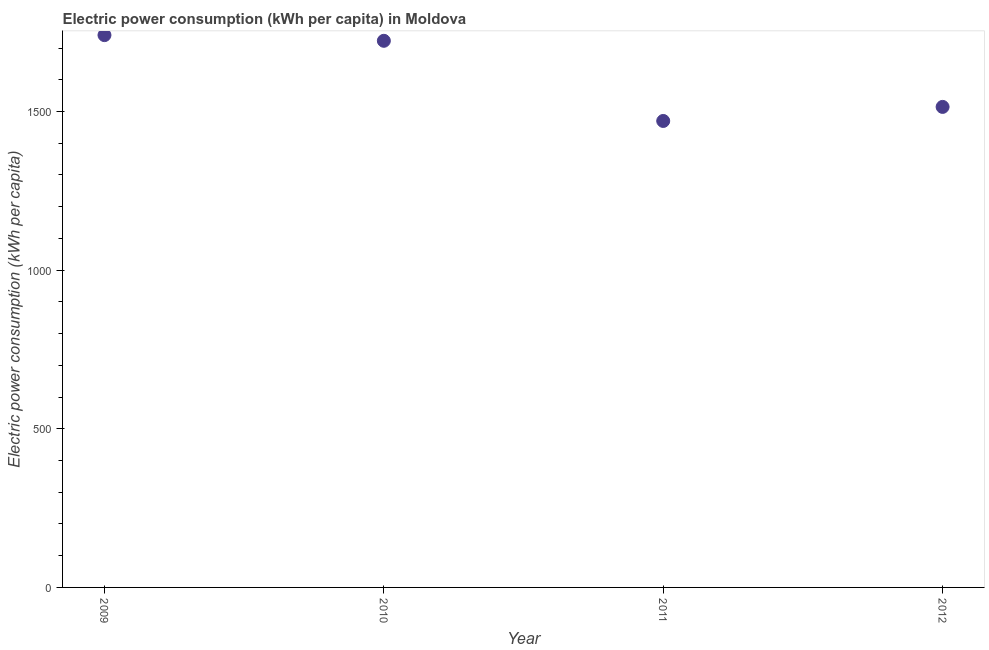What is the electric power consumption in 2009?
Your answer should be compact. 1740.8. Across all years, what is the maximum electric power consumption?
Your response must be concise. 1740.8. Across all years, what is the minimum electric power consumption?
Your answer should be compact. 1470.23. In which year was the electric power consumption minimum?
Provide a short and direct response. 2011. What is the sum of the electric power consumption?
Provide a succinct answer. 6448.45. What is the difference between the electric power consumption in 2009 and 2011?
Give a very brief answer. 270.57. What is the average electric power consumption per year?
Provide a short and direct response. 1612.11. What is the median electric power consumption?
Provide a short and direct response. 1618.71. In how many years, is the electric power consumption greater than 200 kWh per capita?
Offer a very short reply. 4. Do a majority of the years between 2012 and 2011 (inclusive) have electric power consumption greater than 300 kWh per capita?
Provide a succinct answer. No. What is the ratio of the electric power consumption in 2010 to that in 2012?
Offer a very short reply. 1.14. What is the difference between the highest and the second highest electric power consumption?
Your answer should be very brief. 17.91. Is the sum of the electric power consumption in 2009 and 2011 greater than the maximum electric power consumption across all years?
Give a very brief answer. Yes. What is the difference between the highest and the lowest electric power consumption?
Offer a very short reply. 270.57. In how many years, is the electric power consumption greater than the average electric power consumption taken over all years?
Give a very brief answer. 2. Does the electric power consumption monotonically increase over the years?
Offer a terse response. No. How many years are there in the graph?
Provide a short and direct response. 4. Are the values on the major ticks of Y-axis written in scientific E-notation?
Your response must be concise. No. Does the graph contain any zero values?
Provide a succinct answer. No. Does the graph contain grids?
Give a very brief answer. No. What is the title of the graph?
Ensure brevity in your answer.  Electric power consumption (kWh per capita) in Moldova. What is the label or title of the X-axis?
Ensure brevity in your answer.  Year. What is the label or title of the Y-axis?
Your answer should be compact. Electric power consumption (kWh per capita). What is the Electric power consumption (kWh per capita) in 2009?
Your answer should be very brief. 1740.8. What is the Electric power consumption (kWh per capita) in 2010?
Ensure brevity in your answer.  1722.89. What is the Electric power consumption (kWh per capita) in 2011?
Make the answer very short. 1470.23. What is the Electric power consumption (kWh per capita) in 2012?
Offer a very short reply. 1514.53. What is the difference between the Electric power consumption (kWh per capita) in 2009 and 2010?
Provide a short and direct response. 17.91. What is the difference between the Electric power consumption (kWh per capita) in 2009 and 2011?
Your answer should be very brief. 270.57. What is the difference between the Electric power consumption (kWh per capita) in 2009 and 2012?
Your answer should be very brief. 226.27. What is the difference between the Electric power consumption (kWh per capita) in 2010 and 2011?
Your answer should be compact. 252.66. What is the difference between the Electric power consumption (kWh per capita) in 2010 and 2012?
Offer a very short reply. 208.36. What is the difference between the Electric power consumption (kWh per capita) in 2011 and 2012?
Offer a very short reply. -44.3. What is the ratio of the Electric power consumption (kWh per capita) in 2009 to that in 2011?
Your response must be concise. 1.18. What is the ratio of the Electric power consumption (kWh per capita) in 2009 to that in 2012?
Offer a very short reply. 1.15. What is the ratio of the Electric power consumption (kWh per capita) in 2010 to that in 2011?
Give a very brief answer. 1.17. What is the ratio of the Electric power consumption (kWh per capita) in 2010 to that in 2012?
Your answer should be very brief. 1.14. 